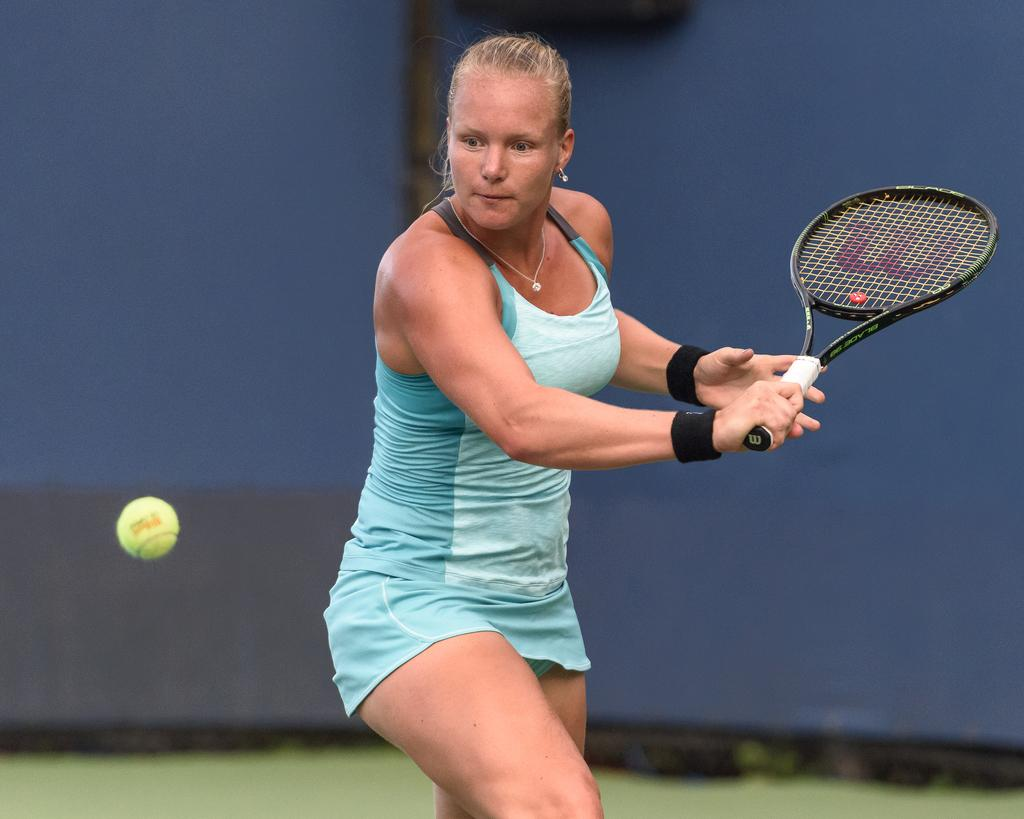What is the woman in the image doing? The woman is playing tennis. What object is the woman using to play tennis? The woman is using a tennis bat. What is the small, round object in the image? There is a tennis ball in the image. What type of machine can be seen in the image? There is no machine present in the image. How many beetles can be seen crawling on the tennis court in the image? There are no beetles present in the image. 